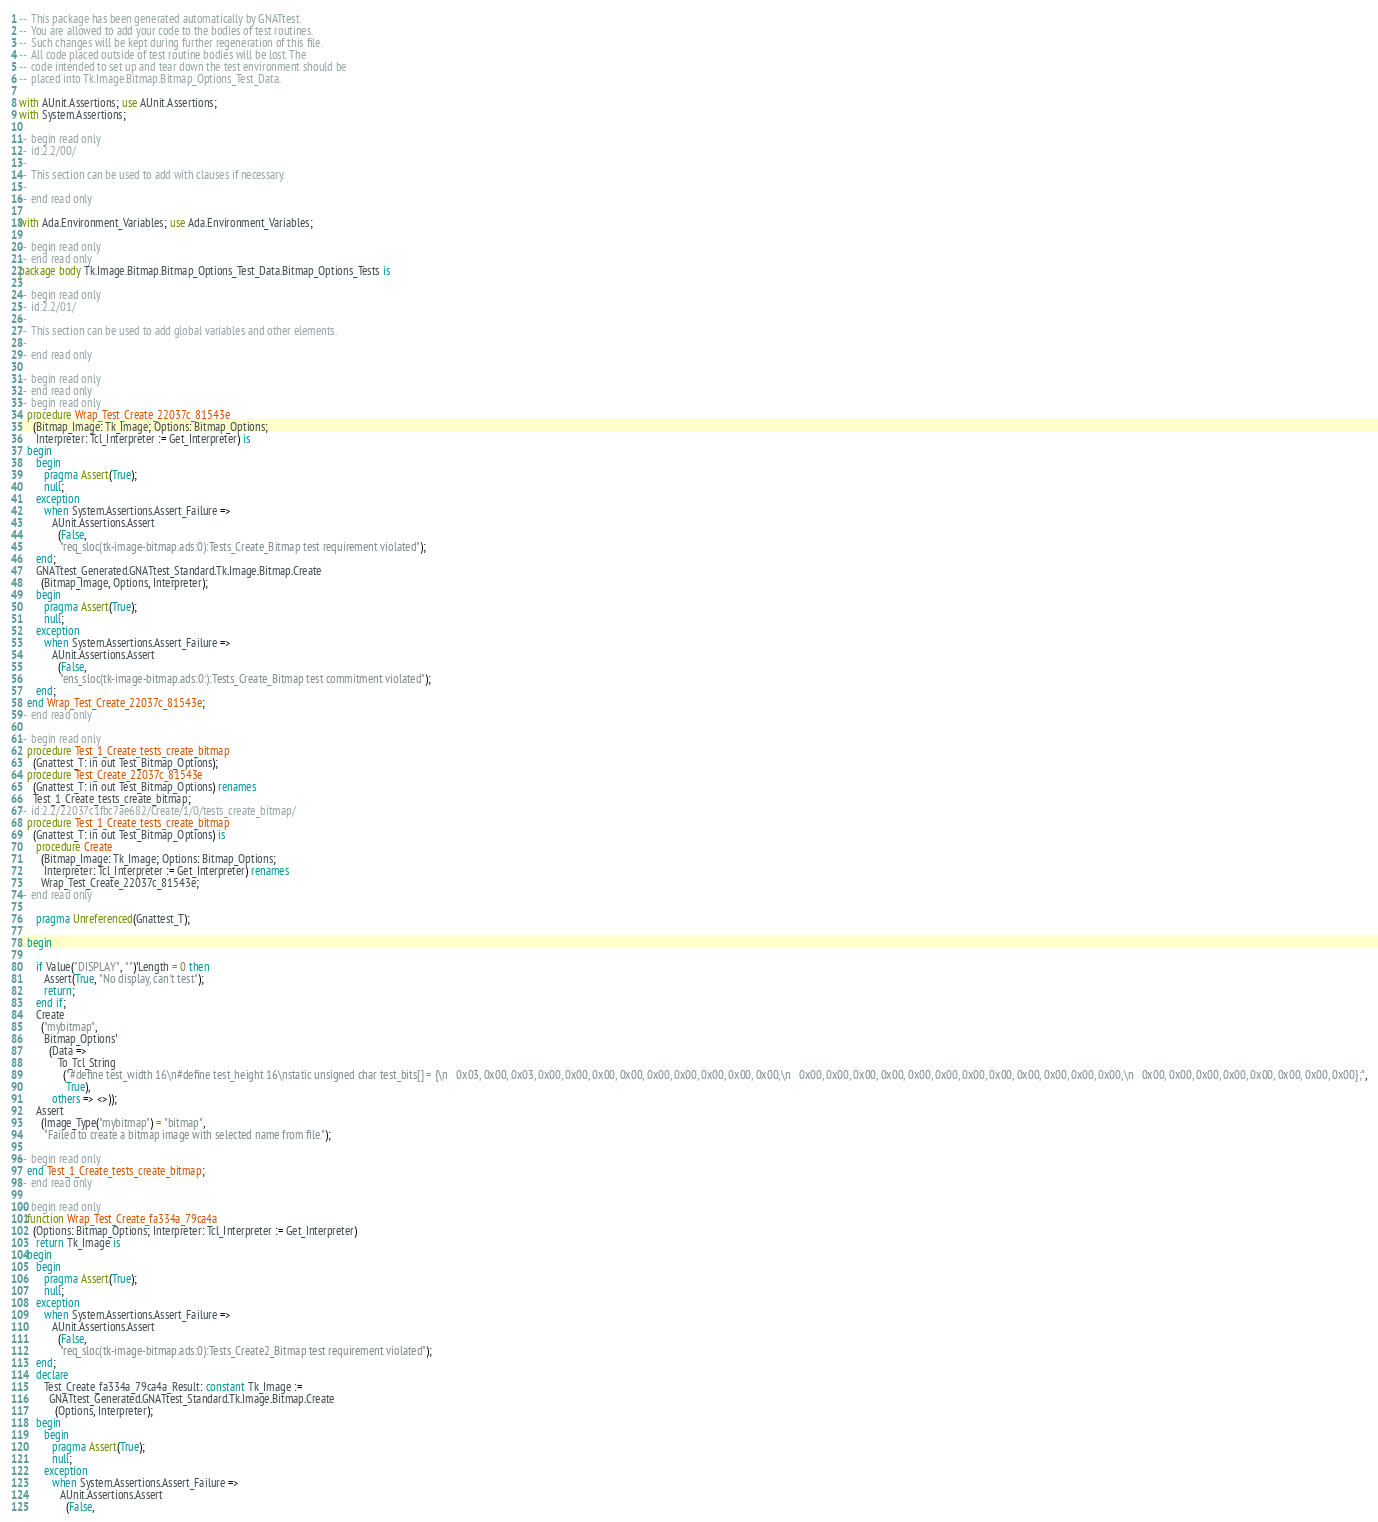<code> <loc_0><loc_0><loc_500><loc_500><_Ada_>--  This package has been generated automatically by GNATtest.
--  You are allowed to add your code to the bodies of test routines.
--  Such changes will be kept during further regeneration of this file.
--  All code placed outside of test routine bodies will be lost. The
--  code intended to set up and tear down the test environment should be
--  placed into Tk.Image.Bitmap.Bitmap_Options_Test_Data.

with AUnit.Assertions; use AUnit.Assertions;
with System.Assertions;

--  begin read only
--  id:2.2/00/
--
--  This section can be used to add with clauses if necessary.
--
--  end read only

with Ada.Environment_Variables; use Ada.Environment_Variables;

--  begin read only
--  end read only
package body Tk.Image.Bitmap.Bitmap_Options_Test_Data.Bitmap_Options_Tests is

--  begin read only
--  id:2.2/01/
--
--  This section can be used to add global variables and other elements.
--
--  end read only

--  begin read only
--  end read only
--  begin read only
   procedure Wrap_Test_Create_22037c_81543e
     (Bitmap_Image: Tk_Image; Options: Bitmap_Options;
      Interpreter: Tcl_Interpreter := Get_Interpreter) is
   begin
      begin
         pragma Assert(True);
         null;
      exception
         when System.Assertions.Assert_Failure =>
            AUnit.Assertions.Assert
              (False,
               "req_sloc(tk-image-bitmap.ads:0):Tests_Create_Bitmap test requirement violated");
      end;
      GNATtest_Generated.GNATtest_Standard.Tk.Image.Bitmap.Create
        (Bitmap_Image, Options, Interpreter);
      begin
         pragma Assert(True);
         null;
      exception
         when System.Assertions.Assert_Failure =>
            AUnit.Assertions.Assert
              (False,
               "ens_sloc(tk-image-bitmap.ads:0:):Tests_Create_Bitmap test commitment violated");
      end;
   end Wrap_Test_Create_22037c_81543e;
--  end read only

--  begin read only
   procedure Test_1_Create_tests_create_bitmap
     (Gnattest_T: in out Test_Bitmap_Options);
   procedure Test_Create_22037c_81543e
     (Gnattest_T: in out Test_Bitmap_Options) renames
     Test_1_Create_tests_create_bitmap;
--  id:2.2/22037c1fbc7ae682/Create/1/0/tests_create_bitmap/
   procedure Test_1_Create_tests_create_bitmap
     (Gnattest_T: in out Test_Bitmap_Options) is
      procedure Create
        (Bitmap_Image: Tk_Image; Options: Bitmap_Options;
         Interpreter: Tcl_Interpreter := Get_Interpreter) renames
        Wrap_Test_Create_22037c_81543e;
--  end read only

      pragma Unreferenced(Gnattest_T);

   begin

      if Value("DISPLAY", "")'Length = 0 then
         Assert(True, "No display, can't test");
         return;
      end if;
      Create
        ("mybitmap",
         Bitmap_Options'
           (Data =>
              To_Tcl_String
                ("#define test_width 16\n#define test_height 16\nstatic unsigned char test_bits[] = {\n   0x03, 0x00, 0x03, 0x00, 0x00, 0x00, 0x00, 0x00, 0x00, 0x00, 0x00, 0x00,\n   0x00, 0x00, 0x00, 0x00, 0x00, 0x00, 0x00, 0x00, 0x00, 0x00, 0x00, 0x00,\n   0x00, 0x00, 0x00, 0x00, 0x00, 0x00, 0x00, 0x00};",
                 True),
            others => <>));
      Assert
        (Image_Type("mybitmap") = "bitmap",
         "Failed to create a bitmap image with selected name from file.");

--  begin read only
   end Test_1_Create_tests_create_bitmap;
--  end read only

--  begin read only
   function Wrap_Test_Create_fa334a_79ca4a
     (Options: Bitmap_Options; Interpreter: Tcl_Interpreter := Get_Interpreter)
      return Tk_Image is
   begin
      begin
         pragma Assert(True);
         null;
      exception
         when System.Assertions.Assert_Failure =>
            AUnit.Assertions.Assert
              (False,
               "req_sloc(tk-image-bitmap.ads:0):Tests_Create2_Bitmap test requirement violated");
      end;
      declare
         Test_Create_fa334a_79ca4a_Result: constant Tk_Image :=
           GNATtest_Generated.GNATtest_Standard.Tk.Image.Bitmap.Create
             (Options, Interpreter);
      begin
         begin
            pragma Assert(True);
            null;
         exception
            when System.Assertions.Assert_Failure =>
               AUnit.Assertions.Assert
                 (False,</code> 